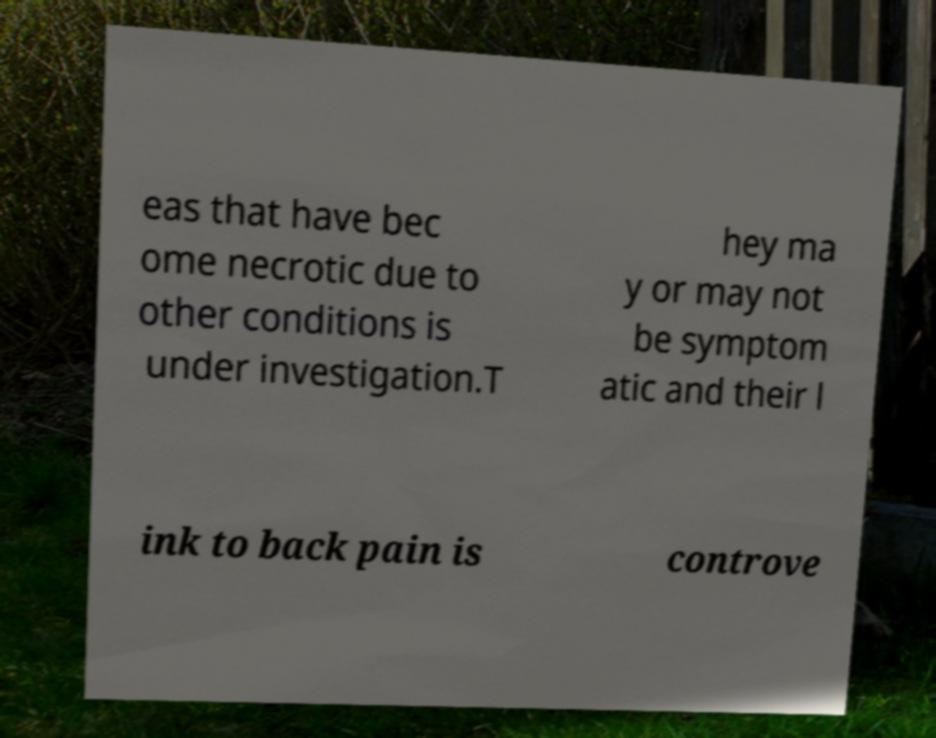Please identify and transcribe the text found in this image. eas that have bec ome necrotic due to other conditions is under investigation.T hey ma y or may not be symptom atic and their l ink to back pain is controve 